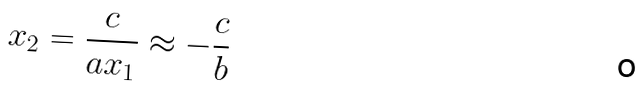Convert formula to latex. <formula><loc_0><loc_0><loc_500><loc_500>x _ { 2 } = \frac { c } { a x _ { 1 } } \approx - \frac { c } { b }</formula> 